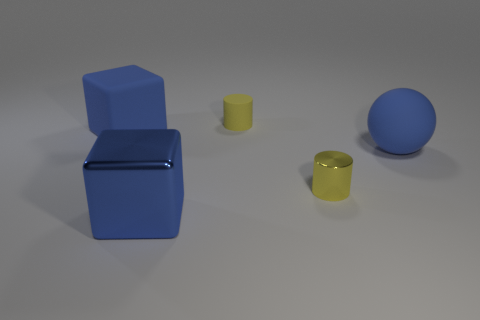Subtract all purple blocks. Subtract all purple cylinders. How many blocks are left? 2 Add 1 small shiny cubes. How many objects exist? 6 Subtract all cylinders. How many objects are left? 3 Add 2 large blue matte objects. How many large blue matte objects are left? 4 Add 1 big matte spheres. How many big matte spheres exist? 2 Subtract 0 purple cubes. How many objects are left? 5 Subtract all small things. Subtract all green rubber things. How many objects are left? 3 